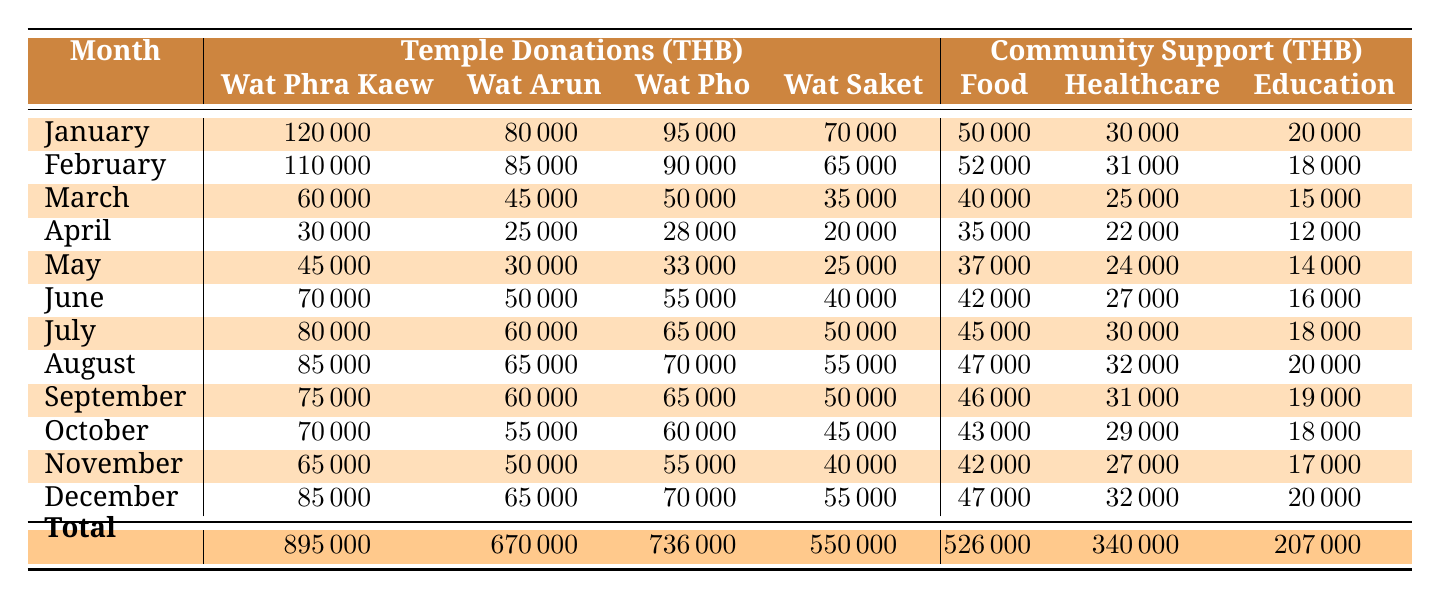What was the total amount of Temple Donations in December? The table lists the Temple Donations in December for each temple: Wat Phra Kaew (85000), Wat Arun (65000), Wat Pho (70000), and Wat Saket (55000). Summing these amounts gives: 85000 + 65000 + 70000 + 55000 = 285000.
Answer: 285000 Which temple received the highest donations in July? From the table, the Temple Donations in July are: Wat Phra Kaew (80000), Wat Arun (60000), Wat Pho (65000), and Wat Saket (50000). The highest amount is 80000 from Wat Phra Kaew.
Answer: Wat Phra Kaew Did community support initiatives see an increase in funding from March to April? In March, the total Community Support was Food (40000), Healthcare (25000), and Education (15000) for a total of 80000. In April, the totals were Food (35000), Healthcare (22000), and Education (12000) for a total of 69000. The funding decreased from 80000 to 69000.
Answer: No What was the average amount of donations received by Wat Arun across all months? The Wat Arun donations for each month were: January (80000), February (85000), March (45000), April (25000), May (30000), June (50000), July (60000), August (65000), September (60000), October (55000), November (50000), December (65000). Summing these gives 80000 + 85000 + 45000 + 25000 + 30000 + 50000 + 60000 + 65000 + 60000 + 55000 + 50000 + 65000 = 670000. There are 12 months, so the average is 670000/12 = 55833.33.
Answer: 55833.33 What is the total amount of funds allocated to Healthcare Support across all months? The Healthcare Support values are: January (30000), February (31000), March (25000), April (22000), May (24000), June (27000), July (30000), August (32000), September (31000), October (29000), November (27000), December (32000). Summing these provides: 30000 + 31000 + 25000 + 22000 + 24000 + 27000 + 30000 + 32000 + 31000 + 29000 + 27000 + 32000 = 340000.
Answer: 340000 Was the Education Support higher in May compared to April? The Education Support values are: April (12000) and May (14000). Comparing these numbers shows that 14000 is indeed higher than 12000, indicating an increase.
Answer: Yes 